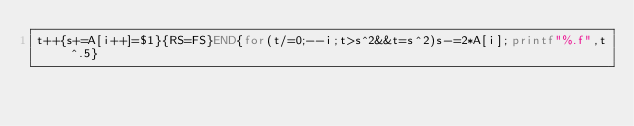Convert code to text. <code><loc_0><loc_0><loc_500><loc_500><_Awk_>t++{s+=A[i++]=$1}{RS=FS}END{for(t/=0;--i;t>s^2&&t=s^2)s-=2*A[i];printf"%.f",t^.5}</code> 